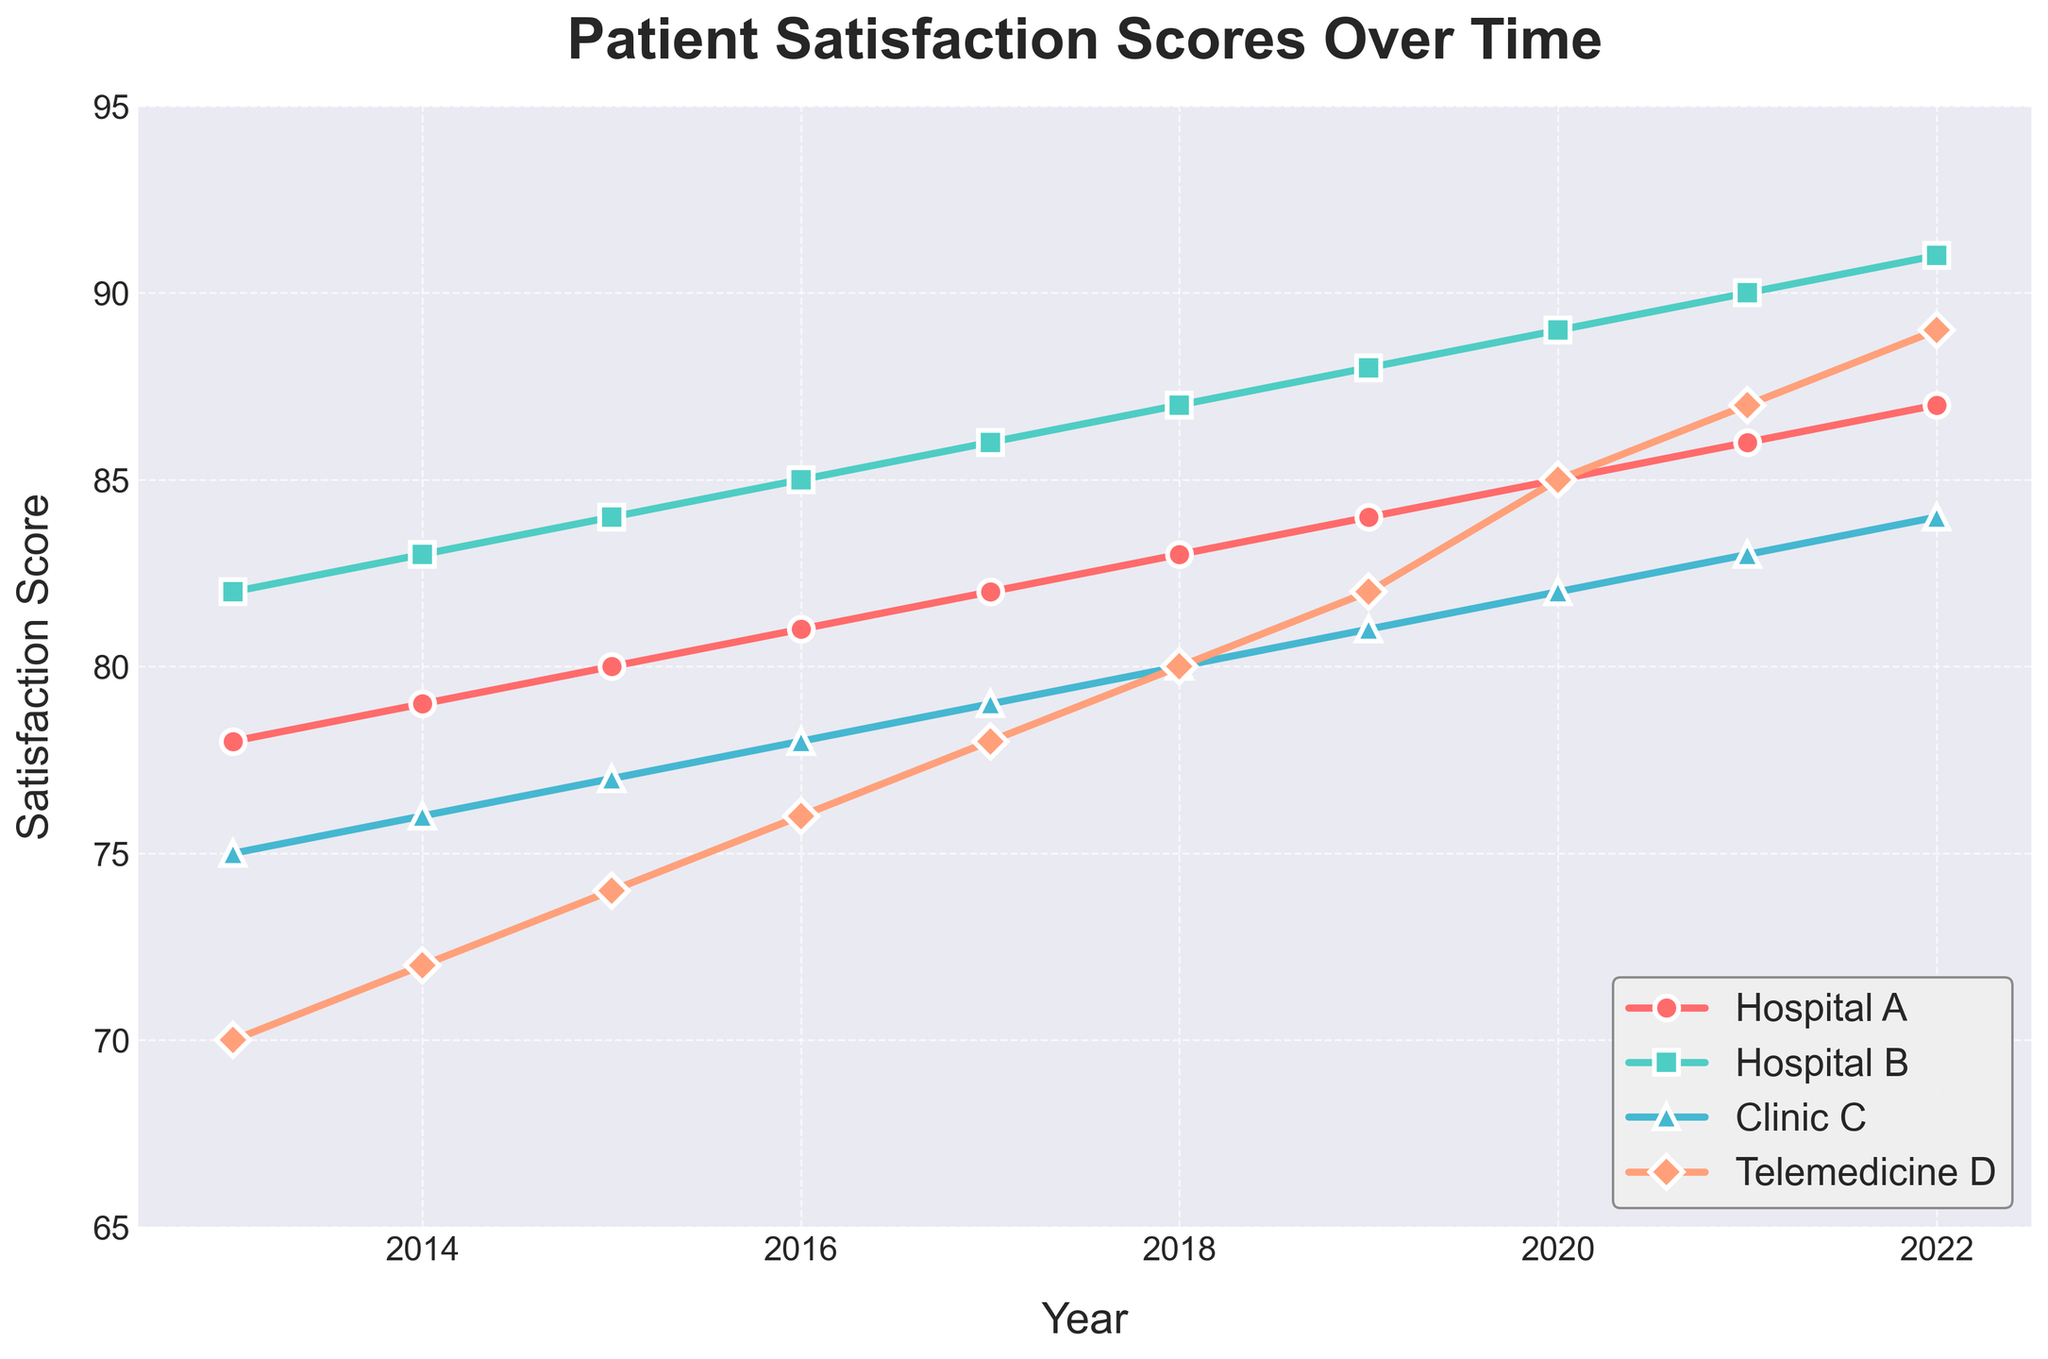What is the general trend in patient satisfaction scores for Hospital A over the past decade? The patient satisfaction scores for Hospital A show a consistent upward trend from 2013 to 2022, increasing year by year without any decline.
Answer: Increasing Which healthcare provider had the highest patient satisfaction score in 2020? In 2020, the highest patient satisfaction score is observed for Hospital B, with a score of 89.
Answer: Hospital B Between Clinic C and Telemedicine D, which had a higher patient satisfaction score in 2019? For the year 2019, Clinic C had a satisfaction score of 81, whereas Telemedicine D had a score of 82. Therefore, Telemedicine D had a higher score.
Answer: Telemedicine D Calculate the average satisfaction score for Hospital A over the past decade. Sum all the scores of Hospital A from 2013 to 2022: (78+79+80+81+82+83+84+85+86+87) = 825. Divide this sum by the number of years (10): 825/10 = 82.5.
Answer: 82.5 Which healthcare provider shows the most improvement in patient satisfaction scores from 2013 to 2022? The improvement is calculated by subtracting the 2013 score from the 2022 score for each provider. 
Hospital A: 87 - 78 = 9 
Hospital B: 91 - 82 = 9 
Clinic C: 84 - 75 = 9 
Telemedicine D: 89 - 70 = 19
Telemedicine D shows the most improvement with an increase of 19 points.
Answer: Telemedicine D During which year did Clinic C surpass a satisfaction score of 80? Clinic C surpassed a satisfaction score of 80 in the year 2019.
Answer: 2019 Compare the patient satisfaction score trend lines for Hospital B and Telemedicine D from 2017 to 2022. Which one shows a steeper increase? From 2017 to 2022, the score for Hospital B increased from 86 to 91, a rise of 5 points. Telemedicine D increased from 78 to 89, a rise of 11 points. Thus, Telemedicine D shows a steeper increase during this period.
Answer: Telemedicine D What is the difference in the 2022 patient satisfaction scores between Hospital A and Clinic C? The 2022 score for Hospital A is 87 and for Clinic C is 84. The difference is 87 - 84 = 3.
Answer: 3 By looking at the visual attributes, which provider is represented by the green line with triangles on the plot? The green line with triangle markers represents Clinic C.
Answer: Clinic C 